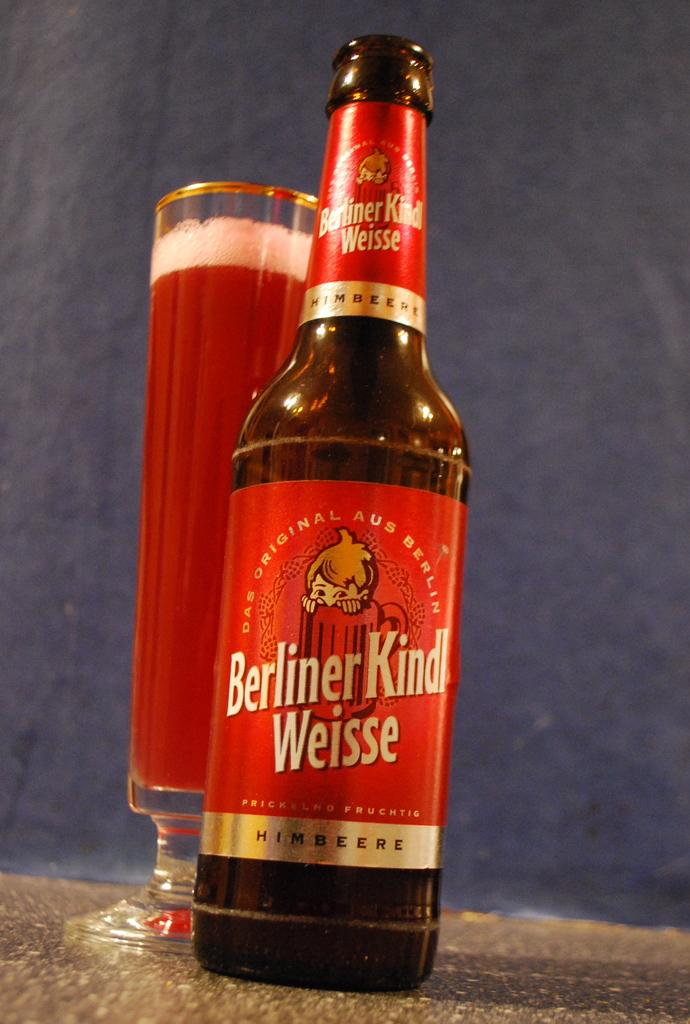<image>
Describe the image concisely. A close photograph of a bottle reading Berliner Kindl Weisse; behind and slightly to the left of the bottle is a tall, footed glass containing a deep red beverage. 